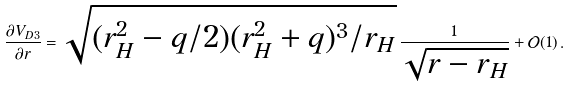Convert formula to latex. <formula><loc_0><loc_0><loc_500><loc_500>\frac { \partial V _ { D 3 } } { \partial r } = \sqrt { ( r _ { H } ^ { 2 } - q / 2 ) ( r _ { H } ^ { 2 } + q ) ^ { 3 } / r _ { H } } \, \frac { 1 } { \sqrt { r - r _ { H } } } + \mathcal { O } ( 1 ) \, .</formula> 